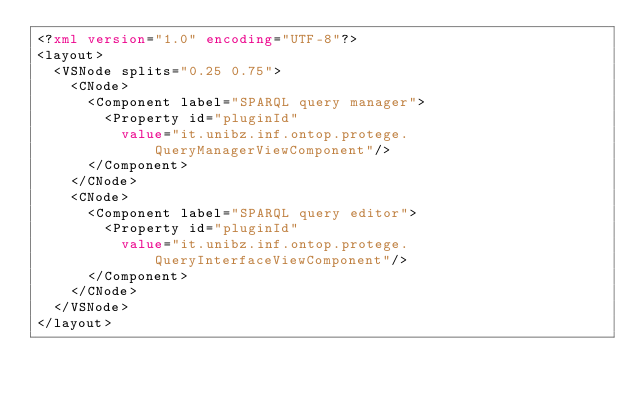Convert code to text. <code><loc_0><loc_0><loc_500><loc_500><_XML_><?xml version="1.0" encoding="UTF-8"?>
<layout>
	<VSNode splits="0.25 0.75">
		<CNode>
			<Component label="SPARQL query manager">
				<Property id="pluginId"
					value="it.unibz.inf.ontop.protege.QueryManagerViewComponent"/>
			</Component>
		</CNode>
		<CNode>
			<Component label="SPARQL query editor">
				<Property id="pluginId"
					value="it.unibz.inf.ontop.protege.QueryInterfaceViewComponent"/>
			</Component>
		</CNode>
	</VSNode>
</layout>
</code> 